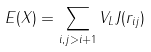<formula> <loc_0><loc_0><loc_500><loc_500>E ( X ) = \sum _ { i , j > i + 1 } V _ { L } J ( r _ { i j } )</formula> 